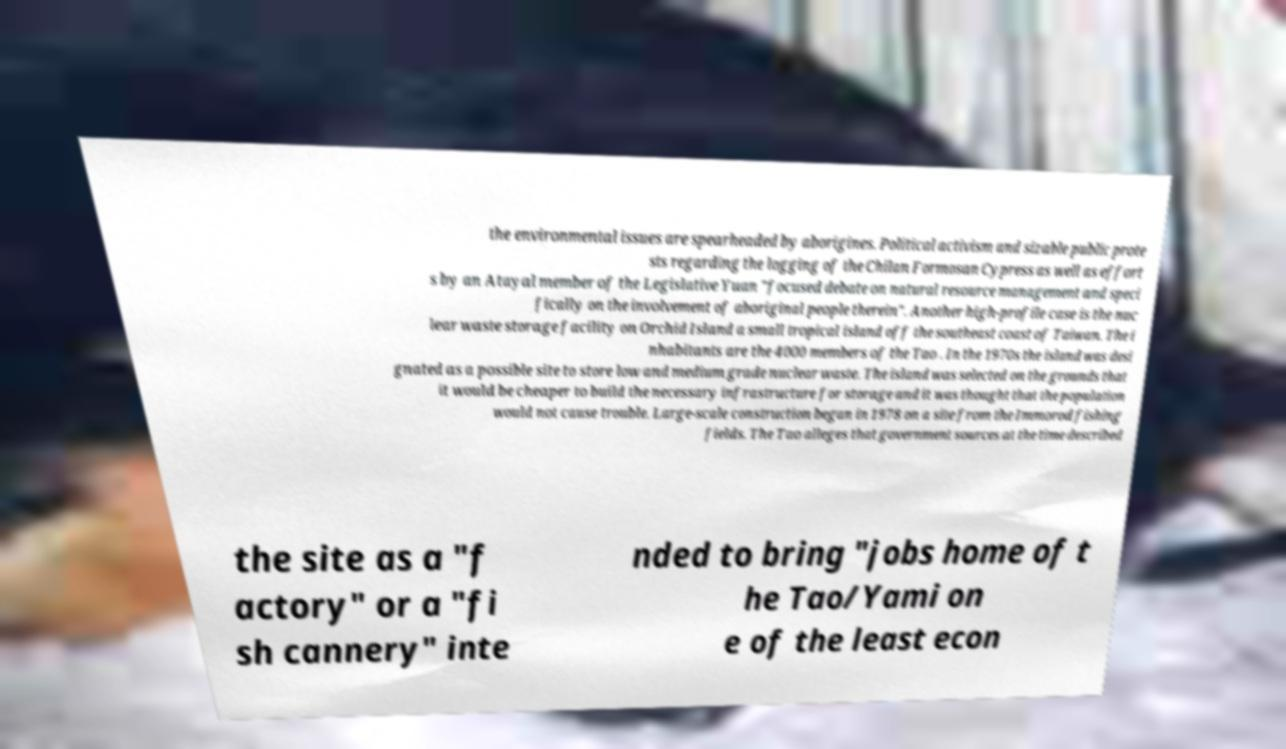For documentation purposes, I need the text within this image transcribed. Could you provide that? the environmental issues are spearheaded by aborigines. Political activism and sizable public prote sts regarding the logging of the Chilan Formosan Cypress as well as effort s by an Atayal member of the Legislative Yuan "focused debate on natural resource management and speci fically on the involvement of aboriginal people therein". Another high-profile case is the nuc lear waste storage facility on Orchid Island a small tropical island off the southeast coast of Taiwan. The i nhabitants are the 4000 members of the Tao . In the 1970s the island was desi gnated as a possible site to store low and medium grade nuclear waste. The island was selected on the grounds that it would be cheaper to build the necessary infrastructure for storage and it was thought that the population would not cause trouble. Large-scale construction began in 1978 on a site from the Immorod fishing fields. The Tao alleges that government sources at the time described the site as a "f actory" or a "fi sh cannery" inte nded to bring "jobs home of t he Tao/Yami on e of the least econ 